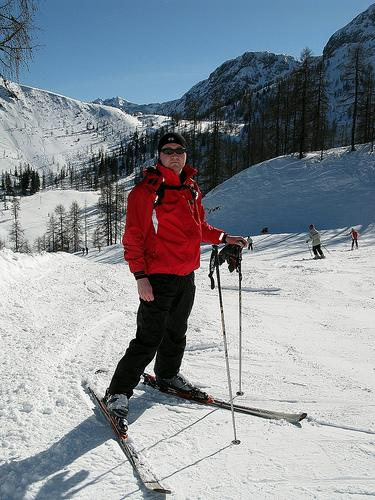Explain if the man in the image is wearing any eye protection or not. Yes, the man is wearing sunglasses to protect his eyes from the sun and snow glare. Can you infer the emotion or sentiment of the scene in the image? The scene appears to be joyful and exciting with people enjoying skiing. Evaluate the image quality based on the details provided in the image. The image quality seems to be good, as it captures multiple objects, people, and details in the scenery. Briefly describe the overall appearance of the man's ski outfit. The man is wearing a red coat, black ski pants, black shoes, and a black cap, while holding white ski poles. How many people can be seen skiing in the distance behind the main subject? There are multiple people skiing in the distance. Analyze the interaction between the man and the ski poles he's holding. He has his hand on the pole, indicating he is using them for support and balance while skiing. What type of outdoor activity is the man in the image participating in? The man is participating in skiing. What color is the sky in the image, and are there any specific weather conditions? The sky is blue and clear, indicating good weather. Identify the color of the cap worn by the man in the image. The man is wearing a black cap. Count the number of pairs of skis mentioned in the image. There are two pairs of skis described - red and black skis, and two black snow skis. 